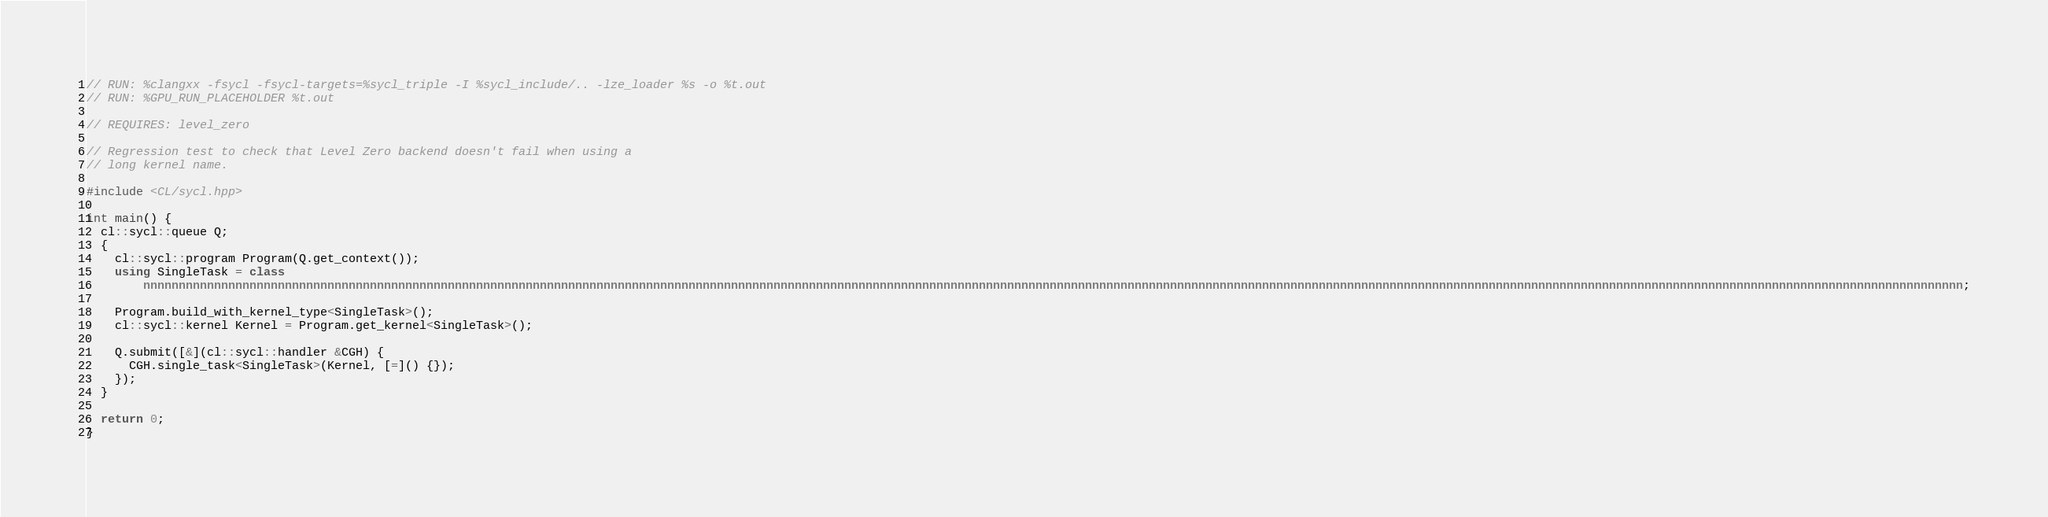Convert code to text. <code><loc_0><loc_0><loc_500><loc_500><_C++_>// RUN: %clangxx -fsycl -fsycl-targets=%sycl_triple -I %sycl_include/.. -lze_loader %s -o %t.out
// RUN: %GPU_RUN_PLACEHOLDER %t.out

// REQUIRES: level_zero

// Regression test to check that Level Zero backend doesn't fail when using a
// long kernel name.

#include <CL/sycl.hpp>

int main() {
  cl::sycl::queue Q;
  {
    cl::sycl::program Program(Q.get_context());
    using SingleTask = class
        nnnnnnnnnnnnnnnnnnnnnnnnnnnnnnnnnnnnnnnnnnnnnnnnnnnnnnnnnnnnnnnnnnnnnnnnnnnnnnnnnnnnnnnnnnnnnnnnnnnnnnnnnnnnnnnnnnnnnnnnnnnnnnnnnnnnnnnnnnnnnnnnnnnnnnnnnnnnnnnnnnnnnnnnnnnnnnnnnnnnnnnnnnnnnnnnnnnnnnnnnnnnnnnnnnnnnnnnnnnnnnnnnnnnnnnnnnnnnnnnnnnnnnnnnnnnnnnnn;

    Program.build_with_kernel_type<SingleTask>();
    cl::sycl::kernel Kernel = Program.get_kernel<SingleTask>();

    Q.submit([&](cl::sycl::handler &CGH) {
      CGH.single_task<SingleTask>(Kernel, [=]() {});
    });
  }

  return 0;
}
</code> 